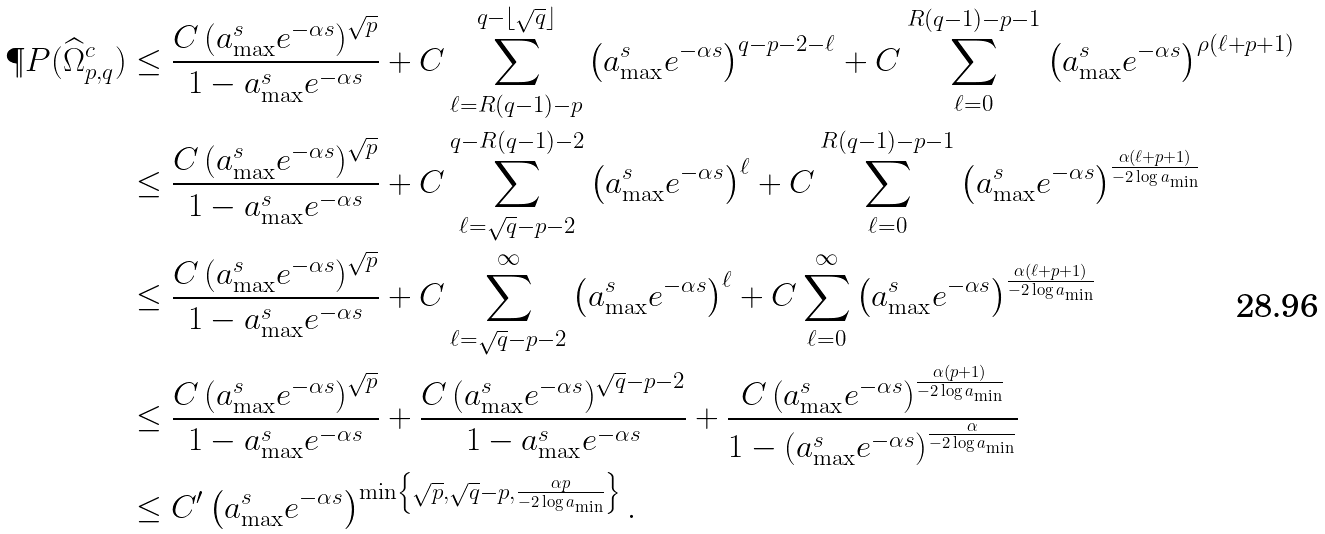<formula> <loc_0><loc_0><loc_500><loc_500>\P P ( \widehat { \Omega } _ { p , q } ^ { c } ) & \leq \frac { C \left ( a _ { \max } ^ { s } e ^ { - \alpha s } \right ) ^ { \sqrt { p } } } { 1 - a _ { \max } ^ { s } e ^ { - \alpha s } } + C \sum _ { \ell = R ( q - 1 ) - p } ^ { q - \lfloor \sqrt { q } \rfloor } \left ( a _ { \max } ^ { s } e ^ { - \alpha s } \right ) ^ { q - p - 2 - \ell } + C \sum _ { \ell = 0 } ^ { R ( q - 1 ) - p - 1 } \left ( a _ { \max } ^ { s } e ^ { - \alpha s } \right ) ^ { \rho ( \ell + p + 1 ) } \\ & \leq \frac { C \left ( a _ { \max } ^ { s } e ^ { - \alpha s } \right ) ^ { \sqrt { p } } } { 1 - a _ { \max } ^ { s } e ^ { - \alpha s } } + C \sum _ { \ell = \sqrt { q } - p - 2 } ^ { q - R ( q - 1 ) - 2 } \left ( a _ { \max } ^ { s } e ^ { - \alpha s } \right ) ^ { \ell } + C \sum _ { \ell = 0 } ^ { R ( q - 1 ) - p - 1 } \left ( a _ { \max } ^ { s } e ^ { - \alpha s } \right ) ^ { \frac { \alpha ( \ell + p + 1 ) } { - 2 \log a _ { \min } } } \\ & \leq \frac { C \left ( a _ { \max } ^ { s } e ^ { - \alpha s } \right ) ^ { \sqrt { p } } } { 1 - a _ { \max } ^ { s } e ^ { - \alpha s } } + C \sum _ { \ell = \sqrt { q } - p - 2 } ^ { \infty } \left ( a _ { \max } ^ { s } e ^ { - \alpha s } \right ) ^ { \ell } + C \sum _ { \ell = 0 } ^ { \infty } \left ( a _ { \max } ^ { s } e ^ { - \alpha s } \right ) ^ { \frac { \alpha ( \ell + p + 1 ) } { - 2 \log a _ { \min } } } \\ & \leq \frac { C \left ( a _ { \max } ^ { s } e ^ { - \alpha s } \right ) ^ { \sqrt { p } } } { 1 - a _ { \max } ^ { s } e ^ { - \alpha s } } + \frac { C \left ( a _ { \max } ^ { s } e ^ { - \alpha s } \right ) ^ { \sqrt { q } - p - 2 } } { 1 - a _ { \max } ^ { s } e ^ { - \alpha s } } + \frac { C \left ( a _ { \max } ^ { s } e ^ { - \alpha s } \right ) ^ { \frac { \alpha ( p + 1 ) } { - 2 \log a _ { \min } } } } { 1 - \left ( a _ { \max } ^ { s } e ^ { - \alpha s } \right ) ^ { \frac { \alpha } { - 2 \log a _ { \min } } } } \\ & \leq C ^ { \prime } \left ( a _ { \max } ^ { s } e ^ { - \alpha s } \right ) ^ { \min \left \{ \sqrt { p } , \sqrt { q } - p , \frac { \alpha p } { - 2 \log a _ { \min } } \right \} } .</formula> 